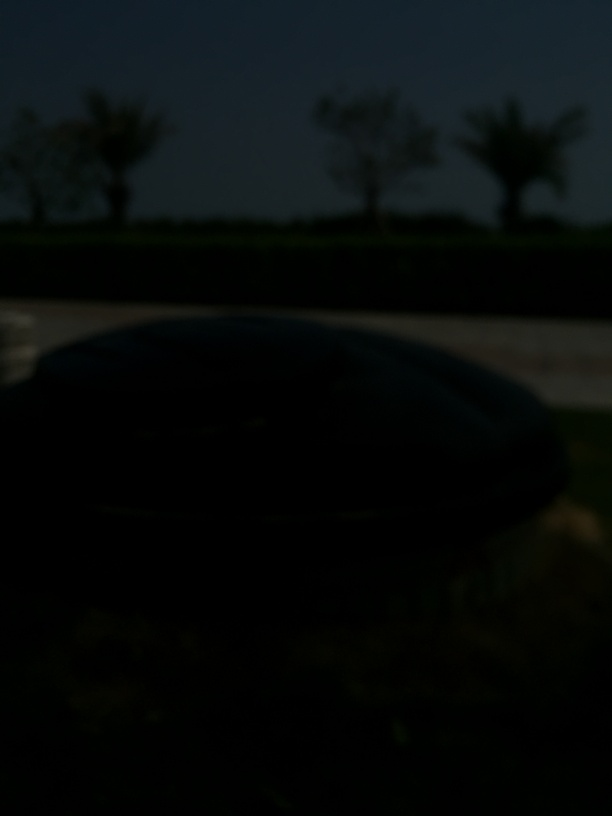Can you describe the setting of this image? While details are difficult to discern due to the underexposure, there appears to be an open outdoor area with trees in the background, possibly a park or roadside scene. 